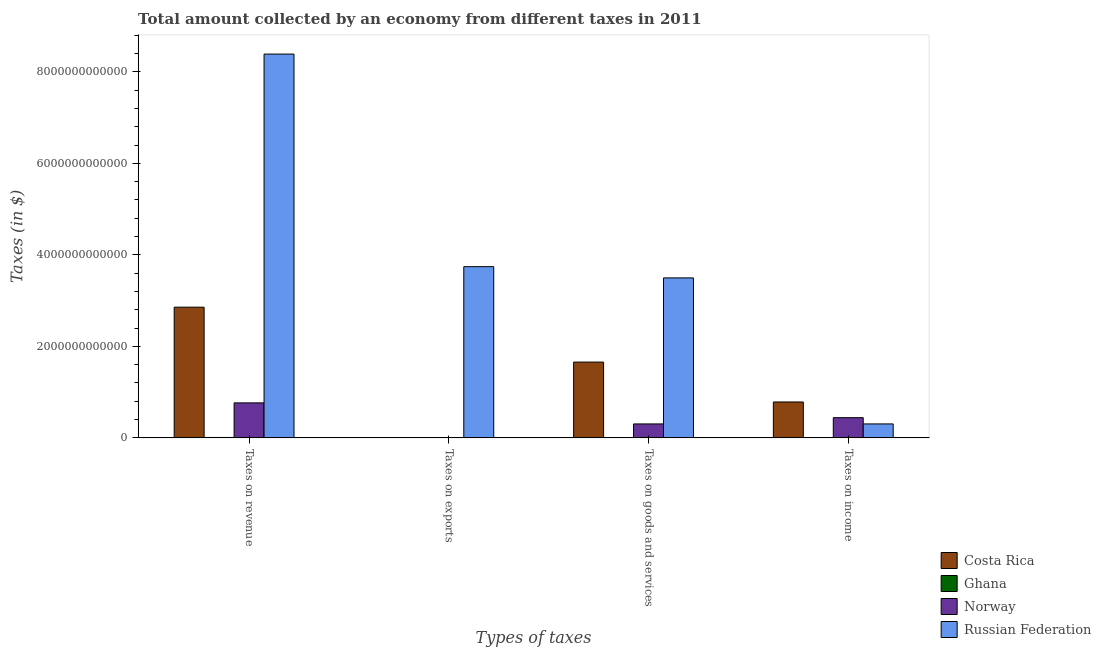How many different coloured bars are there?
Your response must be concise. 4. How many groups of bars are there?
Your response must be concise. 4. Are the number of bars on each tick of the X-axis equal?
Your answer should be compact. Yes. What is the label of the 3rd group of bars from the left?
Offer a very short reply. Taxes on goods and services. What is the amount collected as tax on goods in Costa Rica?
Offer a very short reply. 1.66e+12. Across all countries, what is the maximum amount collected as tax on revenue?
Offer a terse response. 8.39e+12. Across all countries, what is the minimum amount collected as tax on revenue?
Your answer should be compact. 8.89e+09. In which country was the amount collected as tax on revenue maximum?
Your answer should be very brief. Russian Federation. In which country was the amount collected as tax on revenue minimum?
Your answer should be very brief. Ghana. What is the total amount collected as tax on revenue in the graph?
Make the answer very short. 1.20e+13. What is the difference between the amount collected as tax on revenue in Russian Federation and that in Ghana?
Provide a succinct answer. 8.38e+12. What is the difference between the amount collected as tax on revenue in Ghana and the amount collected as tax on exports in Russian Federation?
Give a very brief answer. -3.73e+12. What is the average amount collected as tax on revenue per country?
Offer a very short reply. 3.00e+12. What is the difference between the amount collected as tax on goods and amount collected as tax on income in Norway?
Provide a succinct answer. -1.37e+11. In how many countries, is the amount collected as tax on income greater than 1200000000000 $?
Give a very brief answer. 0. What is the ratio of the amount collected as tax on goods in Ghana to that in Costa Rica?
Your answer should be compact. 0. Is the amount collected as tax on revenue in Ghana less than that in Norway?
Offer a terse response. Yes. What is the difference between the highest and the second highest amount collected as tax on exports?
Keep it short and to the point. 3.74e+12. What is the difference between the highest and the lowest amount collected as tax on exports?
Offer a terse response. 3.74e+12. Is the sum of the amount collected as tax on income in Costa Rica and Ghana greater than the maximum amount collected as tax on exports across all countries?
Keep it short and to the point. No. What does the 3rd bar from the right in Taxes on income represents?
Provide a succinct answer. Ghana. How many bars are there?
Your response must be concise. 16. How many countries are there in the graph?
Keep it short and to the point. 4. What is the difference between two consecutive major ticks on the Y-axis?
Ensure brevity in your answer.  2.00e+12. Are the values on the major ticks of Y-axis written in scientific E-notation?
Your answer should be very brief. No. Does the graph contain any zero values?
Your response must be concise. No. Where does the legend appear in the graph?
Provide a short and direct response. Bottom right. How many legend labels are there?
Offer a terse response. 4. What is the title of the graph?
Offer a terse response. Total amount collected by an economy from different taxes in 2011. What is the label or title of the X-axis?
Keep it short and to the point. Types of taxes. What is the label or title of the Y-axis?
Give a very brief answer. Taxes (in $). What is the Taxes (in $) in Costa Rica in Taxes on revenue?
Your response must be concise. 2.86e+12. What is the Taxes (in $) in Ghana in Taxes on revenue?
Ensure brevity in your answer.  8.89e+09. What is the Taxes (in $) of Norway in Taxes on revenue?
Offer a very short reply. 7.65e+11. What is the Taxes (in $) in Russian Federation in Taxes on revenue?
Your answer should be very brief. 8.39e+12. What is the Taxes (in $) in Costa Rica in Taxes on exports?
Make the answer very short. 3.99e+09. What is the Taxes (in $) of Norway in Taxes on exports?
Ensure brevity in your answer.  1.70e+08. What is the Taxes (in $) of Russian Federation in Taxes on exports?
Your answer should be compact. 3.74e+12. What is the Taxes (in $) in Costa Rica in Taxes on goods and services?
Give a very brief answer. 1.66e+12. What is the Taxes (in $) in Ghana in Taxes on goods and services?
Give a very brief answer. 3.55e+09. What is the Taxes (in $) in Norway in Taxes on goods and services?
Keep it short and to the point. 3.05e+11. What is the Taxes (in $) of Russian Federation in Taxes on goods and services?
Ensure brevity in your answer.  3.50e+12. What is the Taxes (in $) of Costa Rica in Taxes on income?
Offer a terse response. 7.84e+11. What is the Taxes (in $) of Ghana in Taxes on income?
Keep it short and to the point. 3.19e+09. What is the Taxes (in $) in Norway in Taxes on income?
Make the answer very short. 4.42e+11. What is the Taxes (in $) of Russian Federation in Taxes on income?
Make the answer very short. 3.05e+11. Across all Types of taxes, what is the maximum Taxes (in $) of Costa Rica?
Your response must be concise. 2.86e+12. Across all Types of taxes, what is the maximum Taxes (in $) in Ghana?
Your answer should be very brief. 8.89e+09. Across all Types of taxes, what is the maximum Taxes (in $) in Norway?
Ensure brevity in your answer.  7.65e+11. Across all Types of taxes, what is the maximum Taxes (in $) in Russian Federation?
Offer a very short reply. 8.39e+12. Across all Types of taxes, what is the minimum Taxes (in $) of Costa Rica?
Provide a succinct answer. 3.99e+09. Across all Types of taxes, what is the minimum Taxes (in $) in Norway?
Make the answer very short. 1.70e+08. Across all Types of taxes, what is the minimum Taxes (in $) of Russian Federation?
Offer a terse response. 3.05e+11. What is the total Taxes (in $) in Costa Rica in the graph?
Provide a succinct answer. 5.30e+12. What is the total Taxes (in $) of Ghana in the graph?
Give a very brief answer. 1.56e+1. What is the total Taxes (in $) in Norway in the graph?
Your response must be concise. 1.51e+12. What is the total Taxes (in $) of Russian Federation in the graph?
Make the answer very short. 1.59e+13. What is the difference between the Taxes (in $) of Costa Rica in Taxes on revenue and that in Taxes on exports?
Provide a succinct answer. 2.85e+12. What is the difference between the Taxes (in $) of Ghana in Taxes on revenue and that in Taxes on exports?
Your response must be concise. 8.89e+09. What is the difference between the Taxes (in $) in Norway in Taxes on revenue and that in Taxes on exports?
Your response must be concise. 7.65e+11. What is the difference between the Taxes (in $) of Russian Federation in Taxes on revenue and that in Taxes on exports?
Keep it short and to the point. 4.65e+12. What is the difference between the Taxes (in $) in Costa Rica in Taxes on revenue and that in Taxes on goods and services?
Offer a very short reply. 1.20e+12. What is the difference between the Taxes (in $) of Ghana in Taxes on revenue and that in Taxes on goods and services?
Your answer should be compact. 5.34e+09. What is the difference between the Taxes (in $) in Norway in Taxes on revenue and that in Taxes on goods and services?
Ensure brevity in your answer.  4.60e+11. What is the difference between the Taxes (in $) in Russian Federation in Taxes on revenue and that in Taxes on goods and services?
Your response must be concise. 4.89e+12. What is the difference between the Taxes (in $) of Costa Rica in Taxes on revenue and that in Taxes on income?
Keep it short and to the point. 2.07e+12. What is the difference between the Taxes (in $) of Ghana in Taxes on revenue and that in Taxes on income?
Your response must be concise. 5.70e+09. What is the difference between the Taxes (in $) in Norway in Taxes on revenue and that in Taxes on income?
Offer a terse response. 3.23e+11. What is the difference between the Taxes (in $) in Russian Federation in Taxes on revenue and that in Taxes on income?
Give a very brief answer. 8.08e+12. What is the difference between the Taxes (in $) of Costa Rica in Taxes on exports and that in Taxes on goods and services?
Your answer should be compact. -1.65e+12. What is the difference between the Taxes (in $) of Ghana in Taxes on exports and that in Taxes on goods and services?
Provide a short and direct response. -3.54e+09. What is the difference between the Taxes (in $) in Norway in Taxes on exports and that in Taxes on goods and services?
Ensure brevity in your answer.  -3.05e+11. What is the difference between the Taxes (in $) of Russian Federation in Taxes on exports and that in Taxes on goods and services?
Your response must be concise. 2.46e+11. What is the difference between the Taxes (in $) of Costa Rica in Taxes on exports and that in Taxes on income?
Offer a terse response. -7.80e+11. What is the difference between the Taxes (in $) of Ghana in Taxes on exports and that in Taxes on income?
Keep it short and to the point. -3.19e+09. What is the difference between the Taxes (in $) in Norway in Taxes on exports and that in Taxes on income?
Provide a succinct answer. -4.42e+11. What is the difference between the Taxes (in $) of Russian Federation in Taxes on exports and that in Taxes on income?
Give a very brief answer. 3.44e+12. What is the difference between the Taxes (in $) in Costa Rica in Taxes on goods and services and that in Taxes on income?
Offer a very short reply. 8.72e+11. What is the difference between the Taxes (in $) of Ghana in Taxes on goods and services and that in Taxes on income?
Your answer should be very brief. 3.56e+08. What is the difference between the Taxes (in $) in Norway in Taxes on goods and services and that in Taxes on income?
Provide a short and direct response. -1.37e+11. What is the difference between the Taxes (in $) of Russian Federation in Taxes on goods and services and that in Taxes on income?
Your answer should be compact. 3.19e+12. What is the difference between the Taxes (in $) in Costa Rica in Taxes on revenue and the Taxes (in $) in Ghana in Taxes on exports?
Give a very brief answer. 2.86e+12. What is the difference between the Taxes (in $) of Costa Rica in Taxes on revenue and the Taxes (in $) of Norway in Taxes on exports?
Provide a succinct answer. 2.86e+12. What is the difference between the Taxes (in $) of Costa Rica in Taxes on revenue and the Taxes (in $) of Russian Federation in Taxes on exports?
Your answer should be very brief. -8.86e+11. What is the difference between the Taxes (in $) of Ghana in Taxes on revenue and the Taxes (in $) of Norway in Taxes on exports?
Your answer should be compact. 8.72e+09. What is the difference between the Taxes (in $) in Ghana in Taxes on revenue and the Taxes (in $) in Russian Federation in Taxes on exports?
Give a very brief answer. -3.73e+12. What is the difference between the Taxes (in $) of Norway in Taxes on revenue and the Taxes (in $) of Russian Federation in Taxes on exports?
Give a very brief answer. -2.98e+12. What is the difference between the Taxes (in $) in Costa Rica in Taxes on revenue and the Taxes (in $) in Ghana in Taxes on goods and services?
Offer a terse response. 2.85e+12. What is the difference between the Taxes (in $) of Costa Rica in Taxes on revenue and the Taxes (in $) of Norway in Taxes on goods and services?
Your answer should be compact. 2.55e+12. What is the difference between the Taxes (in $) of Costa Rica in Taxes on revenue and the Taxes (in $) of Russian Federation in Taxes on goods and services?
Your response must be concise. -6.40e+11. What is the difference between the Taxes (in $) of Ghana in Taxes on revenue and the Taxes (in $) of Norway in Taxes on goods and services?
Make the answer very short. -2.96e+11. What is the difference between the Taxes (in $) of Ghana in Taxes on revenue and the Taxes (in $) of Russian Federation in Taxes on goods and services?
Ensure brevity in your answer.  -3.49e+12. What is the difference between the Taxes (in $) of Norway in Taxes on revenue and the Taxes (in $) of Russian Federation in Taxes on goods and services?
Your answer should be compact. -2.73e+12. What is the difference between the Taxes (in $) of Costa Rica in Taxes on revenue and the Taxes (in $) of Ghana in Taxes on income?
Your answer should be very brief. 2.85e+12. What is the difference between the Taxes (in $) of Costa Rica in Taxes on revenue and the Taxes (in $) of Norway in Taxes on income?
Your answer should be compact. 2.41e+12. What is the difference between the Taxes (in $) of Costa Rica in Taxes on revenue and the Taxes (in $) of Russian Federation in Taxes on income?
Provide a succinct answer. 2.55e+12. What is the difference between the Taxes (in $) in Ghana in Taxes on revenue and the Taxes (in $) in Norway in Taxes on income?
Keep it short and to the point. -4.33e+11. What is the difference between the Taxes (in $) of Ghana in Taxes on revenue and the Taxes (in $) of Russian Federation in Taxes on income?
Provide a succinct answer. -2.96e+11. What is the difference between the Taxes (in $) in Norway in Taxes on revenue and the Taxes (in $) in Russian Federation in Taxes on income?
Offer a very short reply. 4.60e+11. What is the difference between the Taxes (in $) in Costa Rica in Taxes on exports and the Taxes (in $) in Ghana in Taxes on goods and services?
Your answer should be compact. 4.42e+08. What is the difference between the Taxes (in $) of Costa Rica in Taxes on exports and the Taxes (in $) of Norway in Taxes on goods and services?
Offer a very short reply. -3.01e+11. What is the difference between the Taxes (in $) in Costa Rica in Taxes on exports and the Taxes (in $) in Russian Federation in Taxes on goods and services?
Offer a terse response. -3.49e+12. What is the difference between the Taxes (in $) in Ghana in Taxes on exports and the Taxes (in $) in Norway in Taxes on goods and services?
Offer a terse response. -3.05e+11. What is the difference between the Taxes (in $) of Ghana in Taxes on exports and the Taxes (in $) of Russian Federation in Taxes on goods and services?
Offer a very short reply. -3.50e+12. What is the difference between the Taxes (in $) of Norway in Taxes on exports and the Taxes (in $) of Russian Federation in Taxes on goods and services?
Provide a short and direct response. -3.50e+12. What is the difference between the Taxes (in $) of Costa Rica in Taxes on exports and the Taxes (in $) of Ghana in Taxes on income?
Your answer should be compact. 7.98e+08. What is the difference between the Taxes (in $) in Costa Rica in Taxes on exports and the Taxes (in $) in Norway in Taxes on income?
Offer a terse response. -4.38e+11. What is the difference between the Taxes (in $) in Costa Rica in Taxes on exports and the Taxes (in $) in Russian Federation in Taxes on income?
Provide a succinct answer. -3.01e+11. What is the difference between the Taxes (in $) in Ghana in Taxes on exports and the Taxes (in $) in Norway in Taxes on income?
Give a very brief answer. -4.42e+11. What is the difference between the Taxes (in $) in Ghana in Taxes on exports and the Taxes (in $) in Russian Federation in Taxes on income?
Make the answer very short. -3.05e+11. What is the difference between the Taxes (in $) in Norway in Taxes on exports and the Taxes (in $) in Russian Federation in Taxes on income?
Ensure brevity in your answer.  -3.04e+11. What is the difference between the Taxes (in $) in Costa Rica in Taxes on goods and services and the Taxes (in $) in Ghana in Taxes on income?
Provide a succinct answer. 1.65e+12. What is the difference between the Taxes (in $) of Costa Rica in Taxes on goods and services and the Taxes (in $) of Norway in Taxes on income?
Ensure brevity in your answer.  1.21e+12. What is the difference between the Taxes (in $) in Costa Rica in Taxes on goods and services and the Taxes (in $) in Russian Federation in Taxes on income?
Ensure brevity in your answer.  1.35e+12. What is the difference between the Taxes (in $) of Ghana in Taxes on goods and services and the Taxes (in $) of Norway in Taxes on income?
Provide a short and direct response. -4.38e+11. What is the difference between the Taxes (in $) in Ghana in Taxes on goods and services and the Taxes (in $) in Russian Federation in Taxes on income?
Your answer should be compact. -3.01e+11. What is the difference between the Taxes (in $) of Norway in Taxes on goods and services and the Taxes (in $) of Russian Federation in Taxes on income?
Provide a short and direct response. 9.00e+07. What is the average Taxes (in $) in Costa Rica per Types of taxes?
Provide a short and direct response. 1.33e+12. What is the average Taxes (in $) of Ghana per Types of taxes?
Give a very brief answer. 3.91e+09. What is the average Taxes (in $) in Norway per Types of taxes?
Give a very brief answer. 3.78e+11. What is the average Taxes (in $) of Russian Federation per Types of taxes?
Ensure brevity in your answer.  3.98e+12. What is the difference between the Taxes (in $) in Costa Rica and Taxes (in $) in Ghana in Taxes on revenue?
Offer a very short reply. 2.85e+12. What is the difference between the Taxes (in $) of Costa Rica and Taxes (in $) of Norway in Taxes on revenue?
Give a very brief answer. 2.09e+12. What is the difference between the Taxes (in $) of Costa Rica and Taxes (in $) of Russian Federation in Taxes on revenue?
Offer a very short reply. -5.53e+12. What is the difference between the Taxes (in $) in Ghana and Taxes (in $) in Norway in Taxes on revenue?
Make the answer very short. -7.56e+11. What is the difference between the Taxes (in $) in Ghana and Taxes (in $) in Russian Federation in Taxes on revenue?
Keep it short and to the point. -8.38e+12. What is the difference between the Taxes (in $) of Norway and Taxes (in $) of Russian Federation in Taxes on revenue?
Make the answer very short. -7.62e+12. What is the difference between the Taxes (in $) of Costa Rica and Taxes (in $) of Ghana in Taxes on exports?
Give a very brief answer. 3.99e+09. What is the difference between the Taxes (in $) of Costa Rica and Taxes (in $) of Norway in Taxes on exports?
Give a very brief answer. 3.82e+09. What is the difference between the Taxes (in $) of Costa Rica and Taxes (in $) of Russian Federation in Taxes on exports?
Provide a succinct answer. -3.74e+12. What is the difference between the Taxes (in $) of Ghana and Taxes (in $) of Norway in Taxes on exports?
Your response must be concise. -1.65e+08. What is the difference between the Taxes (in $) in Ghana and Taxes (in $) in Russian Federation in Taxes on exports?
Offer a very short reply. -3.74e+12. What is the difference between the Taxes (in $) in Norway and Taxes (in $) in Russian Federation in Taxes on exports?
Provide a succinct answer. -3.74e+12. What is the difference between the Taxes (in $) in Costa Rica and Taxes (in $) in Ghana in Taxes on goods and services?
Your response must be concise. 1.65e+12. What is the difference between the Taxes (in $) of Costa Rica and Taxes (in $) of Norway in Taxes on goods and services?
Your answer should be compact. 1.35e+12. What is the difference between the Taxes (in $) of Costa Rica and Taxes (in $) of Russian Federation in Taxes on goods and services?
Your answer should be compact. -1.84e+12. What is the difference between the Taxes (in $) in Ghana and Taxes (in $) in Norway in Taxes on goods and services?
Your response must be concise. -3.01e+11. What is the difference between the Taxes (in $) in Ghana and Taxes (in $) in Russian Federation in Taxes on goods and services?
Provide a succinct answer. -3.49e+12. What is the difference between the Taxes (in $) in Norway and Taxes (in $) in Russian Federation in Taxes on goods and services?
Offer a very short reply. -3.19e+12. What is the difference between the Taxes (in $) of Costa Rica and Taxes (in $) of Ghana in Taxes on income?
Your answer should be compact. 7.81e+11. What is the difference between the Taxes (in $) of Costa Rica and Taxes (in $) of Norway in Taxes on income?
Make the answer very short. 3.43e+11. What is the difference between the Taxes (in $) of Costa Rica and Taxes (in $) of Russian Federation in Taxes on income?
Offer a terse response. 4.80e+11. What is the difference between the Taxes (in $) in Ghana and Taxes (in $) in Norway in Taxes on income?
Give a very brief answer. -4.39e+11. What is the difference between the Taxes (in $) in Ghana and Taxes (in $) in Russian Federation in Taxes on income?
Offer a terse response. -3.01e+11. What is the difference between the Taxes (in $) of Norway and Taxes (in $) of Russian Federation in Taxes on income?
Your answer should be compact. 1.37e+11. What is the ratio of the Taxes (in $) of Costa Rica in Taxes on revenue to that in Taxes on exports?
Make the answer very short. 715.78. What is the ratio of the Taxes (in $) in Ghana in Taxes on revenue to that in Taxes on exports?
Your answer should be compact. 1778.43. What is the ratio of the Taxes (in $) of Norway in Taxes on revenue to that in Taxes on exports?
Ensure brevity in your answer.  4498.41. What is the ratio of the Taxes (in $) in Russian Federation in Taxes on revenue to that in Taxes on exports?
Offer a terse response. 2.24. What is the ratio of the Taxes (in $) of Costa Rica in Taxes on revenue to that in Taxes on goods and services?
Offer a very short reply. 1.72. What is the ratio of the Taxes (in $) of Ghana in Taxes on revenue to that in Taxes on goods and services?
Offer a very short reply. 2.51. What is the ratio of the Taxes (in $) in Norway in Taxes on revenue to that in Taxes on goods and services?
Your answer should be compact. 2.51. What is the ratio of the Taxes (in $) in Russian Federation in Taxes on revenue to that in Taxes on goods and services?
Offer a very short reply. 2.4. What is the ratio of the Taxes (in $) of Costa Rica in Taxes on revenue to that in Taxes on income?
Give a very brief answer. 3.64. What is the ratio of the Taxes (in $) in Ghana in Taxes on revenue to that in Taxes on income?
Give a very brief answer. 2.79. What is the ratio of the Taxes (in $) in Norway in Taxes on revenue to that in Taxes on income?
Keep it short and to the point. 1.73. What is the ratio of the Taxes (in $) of Russian Federation in Taxes on revenue to that in Taxes on income?
Make the answer very short. 27.54. What is the ratio of the Taxes (in $) in Costa Rica in Taxes on exports to that in Taxes on goods and services?
Make the answer very short. 0. What is the ratio of the Taxes (in $) in Ghana in Taxes on exports to that in Taxes on goods and services?
Offer a terse response. 0. What is the ratio of the Taxes (in $) of Norway in Taxes on exports to that in Taxes on goods and services?
Make the answer very short. 0. What is the ratio of the Taxes (in $) in Russian Federation in Taxes on exports to that in Taxes on goods and services?
Your answer should be compact. 1.07. What is the ratio of the Taxes (in $) in Costa Rica in Taxes on exports to that in Taxes on income?
Make the answer very short. 0.01. What is the ratio of the Taxes (in $) of Ghana in Taxes on exports to that in Taxes on income?
Keep it short and to the point. 0. What is the ratio of the Taxes (in $) in Russian Federation in Taxes on exports to that in Taxes on income?
Provide a succinct answer. 12.28. What is the ratio of the Taxes (in $) of Costa Rica in Taxes on goods and services to that in Taxes on income?
Give a very brief answer. 2.11. What is the ratio of the Taxes (in $) in Ghana in Taxes on goods and services to that in Taxes on income?
Make the answer very short. 1.11. What is the ratio of the Taxes (in $) of Norway in Taxes on goods and services to that in Taxes on income?
Ensure brevity in your answer.  0.69. What is the ratio of the Taxes (in $) of Russian Federation in Taxes on goods and services to that in Taxes on income?
Offer a very short reply. 11.48. What is the difference between the highest and the second highest Taxes (in $) in Costa Rica?
Make the answer very short. 1.20e+12. What is the difference between the highest and the second highest Taxes (in $) in Ghana?
Keep it short and to the point. 5.34e+09. What is the difference between the highest and the second highest Taxes (in $) in Norway?
Your answer should be very brief. 3.23e+11. What is the difference between the highest and the second highest Taxes (in $) in Russian Federation?
Your answer should be compact. 4.65e+12. What is the difference between the highest and the lowest Taxes (in $) in Costa Rica?
Your answer should be very brief. 2.85e+12. What is the difference between the highest and the lowest Taxes (in $) of Ghana?
Offer a very short reply. 8.89e+09. What is the difference between the highest and the lowest Taxes (in $) in Norway?
Your answer should be very brief. 7.65e+11. What is the difference between the highest and the lowest Taxes (in $) in Russian Federation?
Make the answer very short. 8.08e+12. 